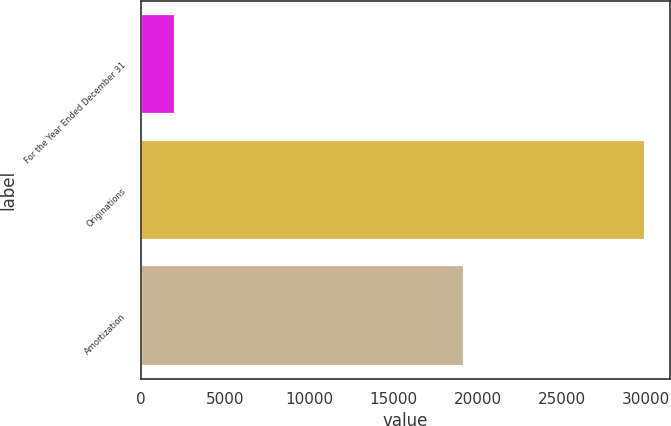Convert chart. <chart><loc_0><loc_0><loc_500><loc_500><bar_chart><fcel>For the Year Ended December 31<fcel>Originations<fcel>Amortization<nl><fcel>2015<fcel>29914<fcel>19161<nl></chart> 